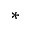<formula> <loc_0><loc_0><loc_500><loc_500>*</formula> 